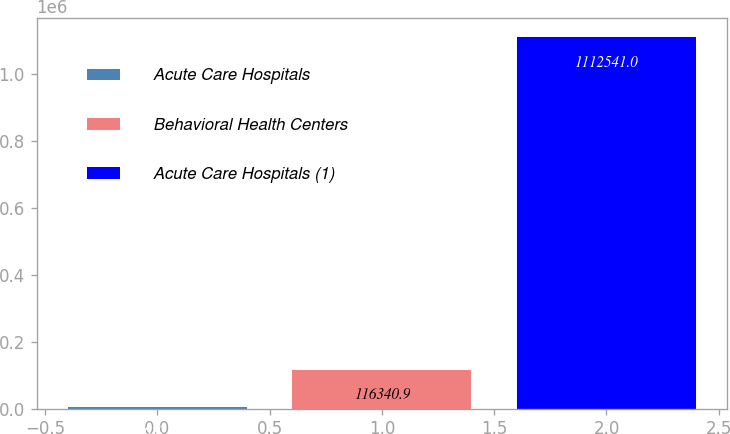<chart> <loc_0><loc_0><loc_500><loc_500><bar_chart><fcel>Acute Care Hospitals<fcel>Behavioral Health Centers<fcel>Acute Care Hospitals (1)<nl><fcel>5652<fcel>116341<fcel>1.11254e+06<nl></chart> 